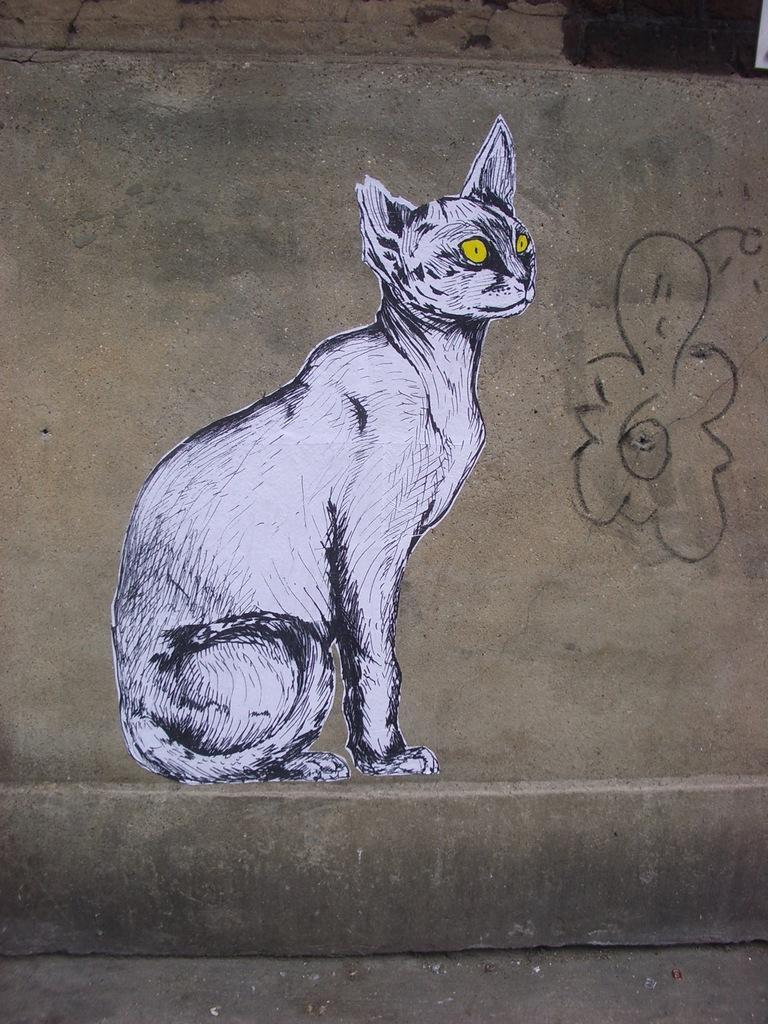Describe this image in one or two sentences. In this picture we can see a wall with a painting of a cat on it. 